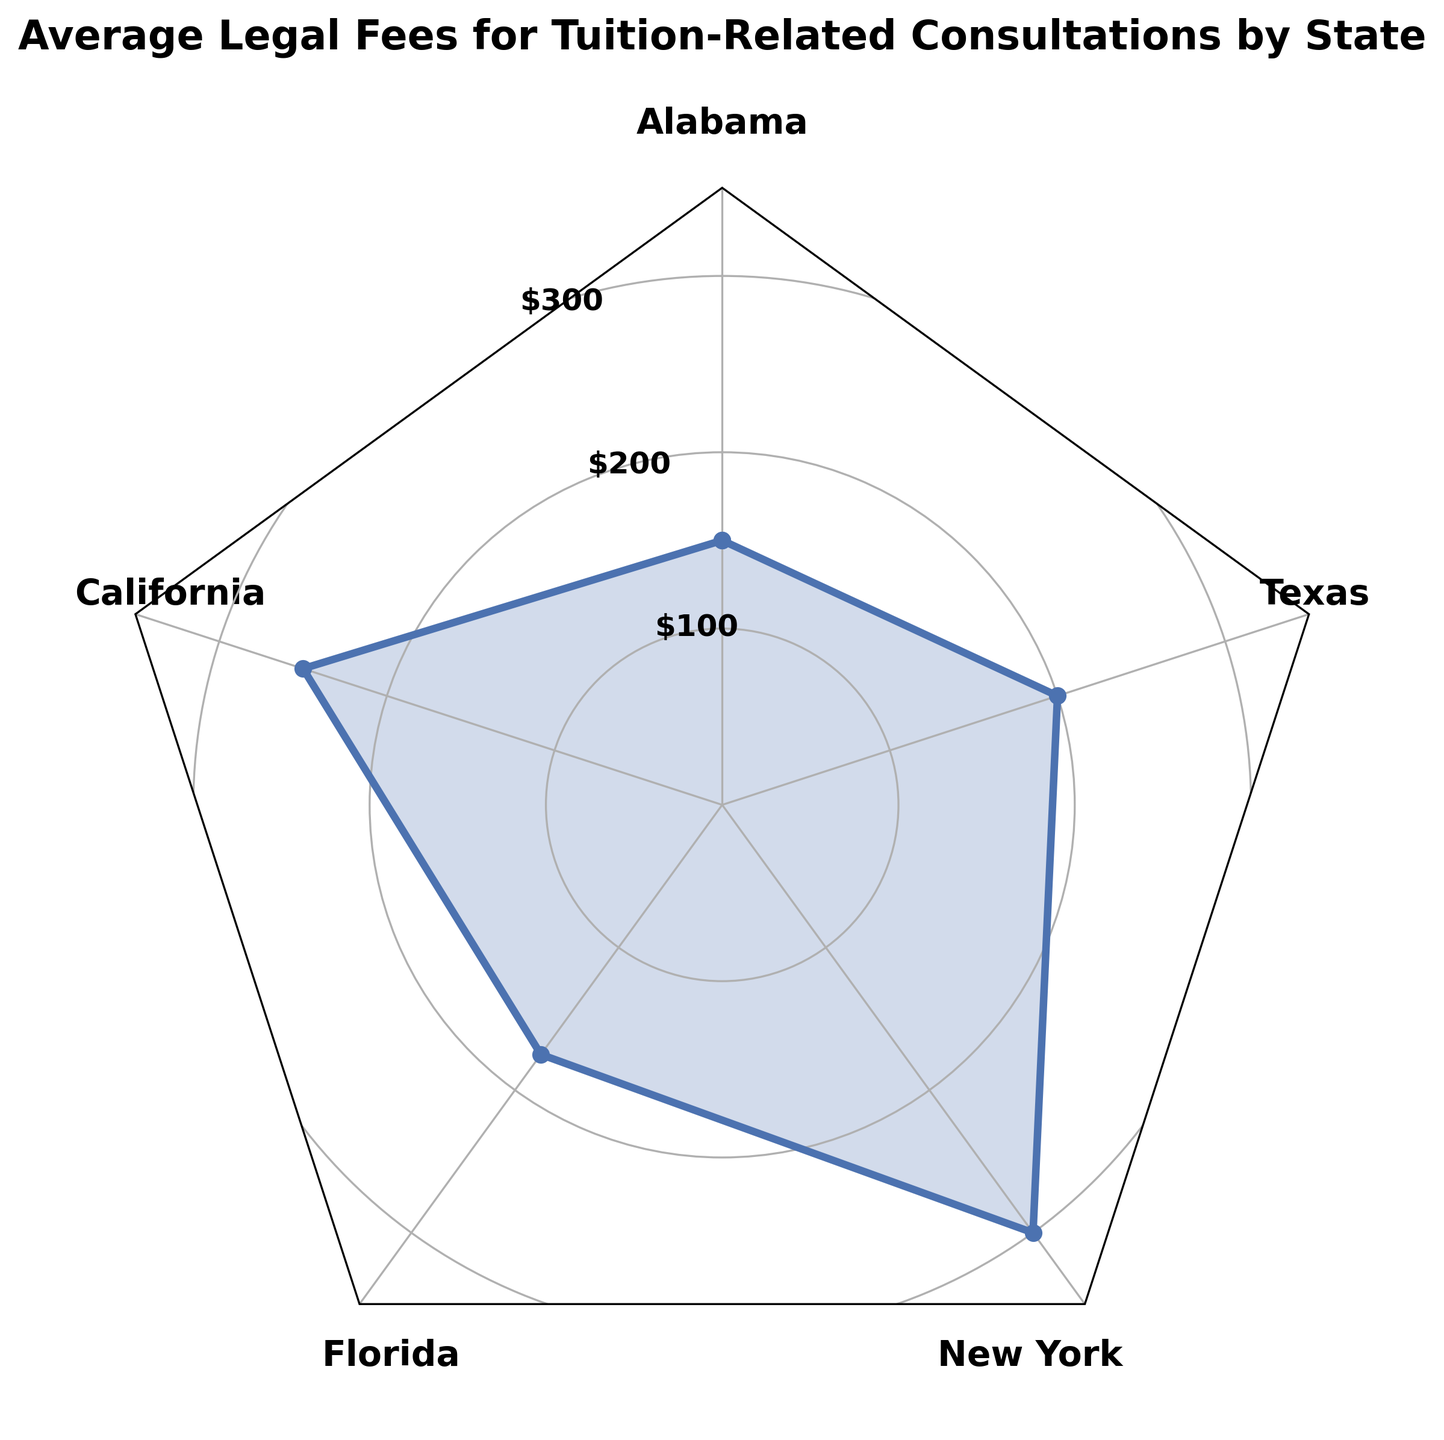What is the title of the radar chart? The title of the chart is usually positioned at the top of the figure. In this case, it states the general subject of the data being visualized.
Answer: Average Legal Fees for Tuition-Related Consultations by State How many states are represented in the radar chart? By counting the number of labeled points around the radar chart, you can determine the number of states.
Answer: 5 Which state has the highest average legal fees for tuition-related consultations? By looking at the outermost point on the radar chart, you can identify which state has the highest values. In this case, it is positioned at $300.
Answer: New York What is the difference between the highest and the lowest average legal fees in this radar chart? Identify the highest value ($300 in New York) and the lowest value ($150 in Alabama) and subtract the lowest from the highest: $300 - $150.
Answer: $150 What is the range of the average legal fees for tuition-related consultations across all represented states? The range is calculated by subtracting the minimum value from the maximum value. Here, the maximum is $300 (New York) and the minimum is $150 (Alabama), so the range is $300 - $150.
Answer: $150 Which state has the median average legal fees, and what is the value? Listing the average legal fees in ascending order: $150 (Alabama), $175 (Florida), $200 (Texas), $250 (California), $300 (New York), the median value falls at the central point ($200 in Texas).
Answer: Texas, $200 What is the sum of the average legal fees for California and Florida? Identify the values for California ($250) and Florida ($175), then sum them: $250 + $175.
Answer: $425 How does the average legal fee in Texas compare to that in Florida? The value for Texas ($200) and for Florida ($175) allows us to see that Texas has a higher average legal fee.
Answer: Texas has a higher average legal fee than Florida What are the radial grid line values used in the radar chart, and how are they labeled? The radial grid lines are set at specific intervals to help benchmark the data values. In this chart, they are at $100, $200, and $300.
Answer: 100, 200, 300 Which states have average legal fees below $200, based on the radar chart? Locate points below the $200 radial grid line. Here, Alabama at $150 and Florida at $175 meet this criterion.
Answer: Alabama, Florida 